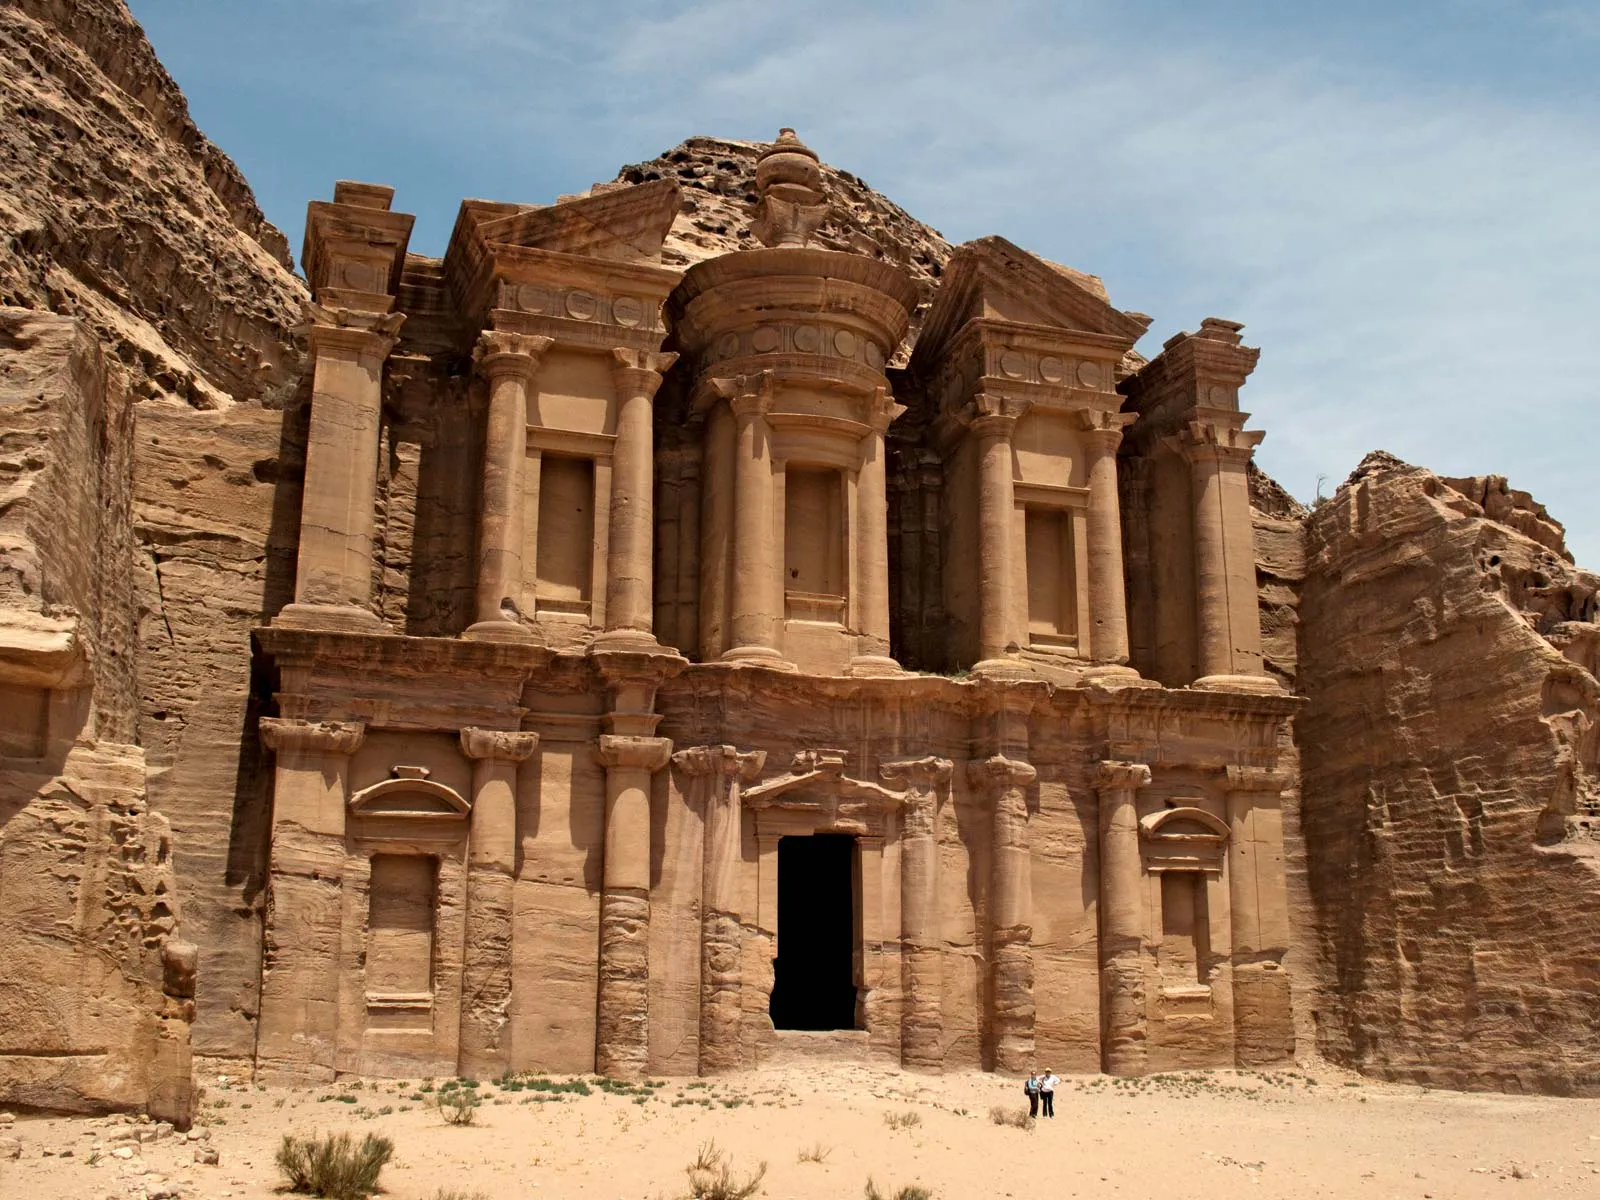What historical events took place around Petra that involve this monument? The Monastery at Petra, while primarily a religious site, has witnessed numerous historical events. During its peak, Petra served as a vital trade hub, connecting the silk and spice routes from the East to the West. The area around the Monastery likely hosted gatherings and served as a backdrop for trade negotiations. It also saw periods of decline, especially following Roman annexation and subsequent introduction of alternative trade routes which led to the city’s gradual desertion. 